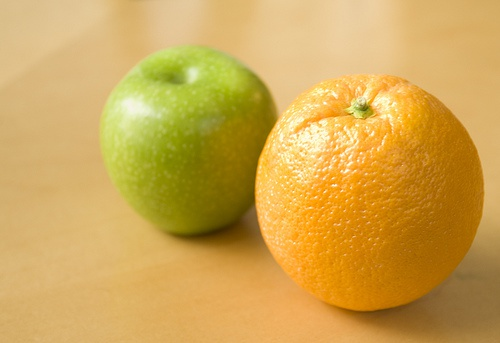Describe the objects in this image and their specific colors. I can see dining table in tan, olive, and orange tones, orange in tan, orange, olive, and gold tones, and apple in tan, olive, and khaki tones in this image. 